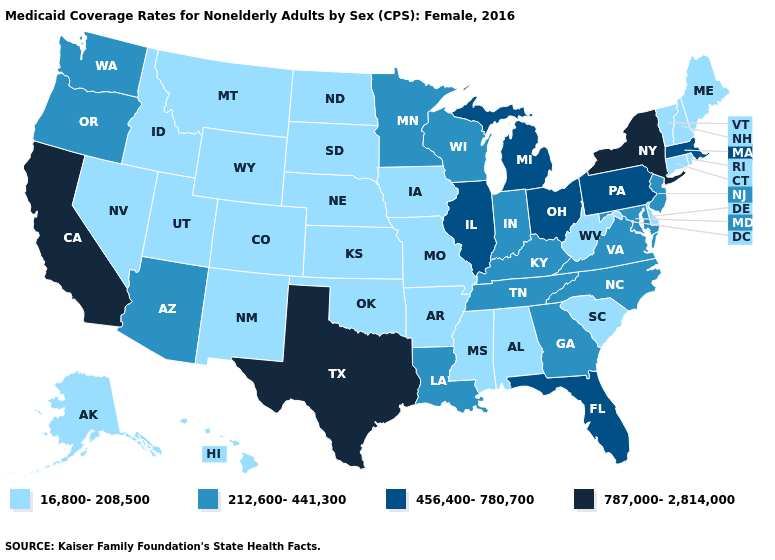What is the highest value in the MidWest ?
Quick response, please. 456,400-780,700. Which states have the highest value in the USA?
Quick response, please. California, New York, Texas. Does the map have missing data?
Quick response, please. No. What is the value of Colorado?
Answer briefly. 16,800-208,500. Name the states that have a value in the range 16,800-208,500?
Answer briefly. Alabama, Alaska, Arkansas, Colorado, Connecticut, Delaware, Hawaii, Idaho, Iowa, Kansas, Maine, Mississippi, Missouri, Montana, Nebraska, Nevada, New Hampshire, New Mexico, North Dakota, Oklahoma, Rhode Island, South Carolina, South Dakota, Utah, Vermont, West Virginia, Wyoming. Does Maine have the lowest value in the USA?
Keep it brief. Yes. Is the legend a continuous bar?
Short answer required. No. Among the states that border Washington , does Idaho have the highest value?
Be succinct. No. Which states have the lowest value in the MidWest?
Answer briefly. Iowa, Kansas, Missouri, Nebraska, North Dakota, South Dakota. What is the highest value in the USA?
Keep it brief. 787,000-2,814,000. Does Michigan have the lowest value in the USA?
Concise answer only. No. What is the lowest value in the USA?
Give a very brief answer. 16,800-208,500. What is the lowest value in the South?
Quick response, please. 16,800-208,500. Name the states that have a value in the range 787,000-2,814,000?
Quick response, please. California, New York, Texas. Does Kentucky have the highest value in the USA?
Answer briefly. No. 